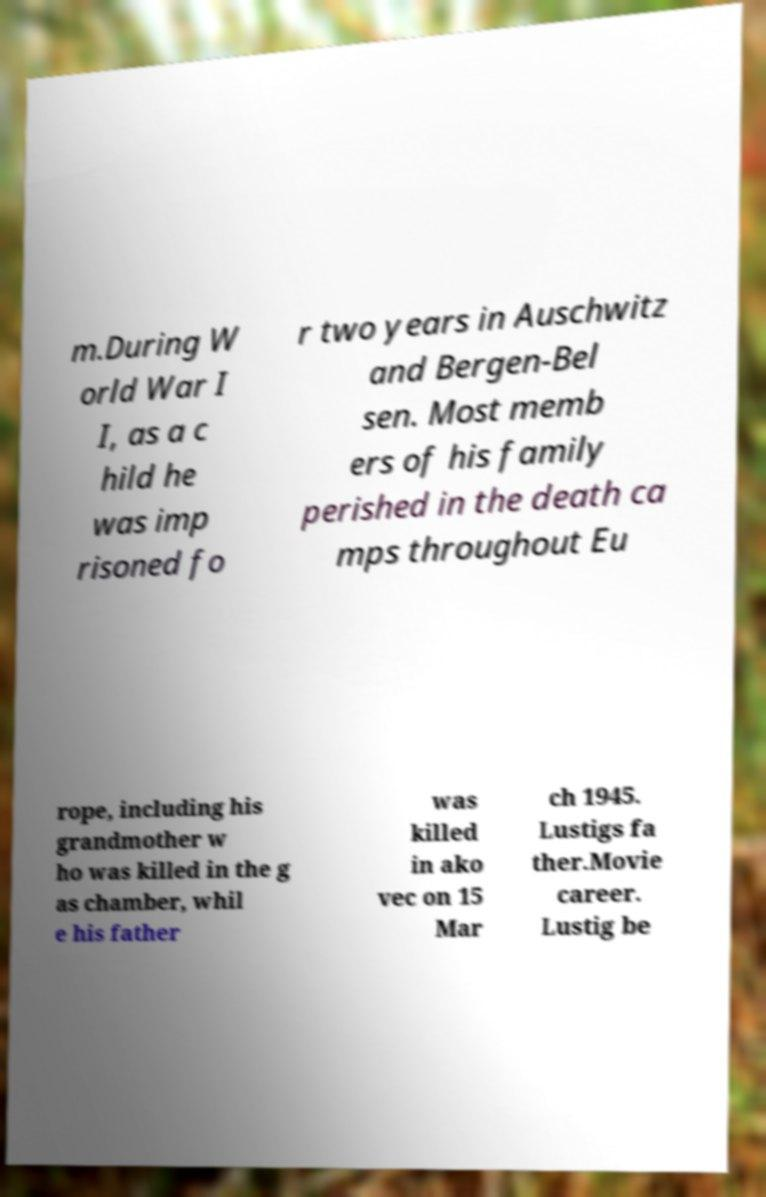Can you accurately transcribe the text from the provided image for me? m.During W orld War I I, as a c hild he was imp risoned fo r two years in Auschwitz and Bergen-Bel sen. Most memb ers of his family perished in the death ca mps throughout Eu rope, including his grandmother w ho was killed in the g as chamber, whil e his father was killed in ako vec on 15 Mar ch 1945. Lustigs fa ther.Movie career. Lustig be 